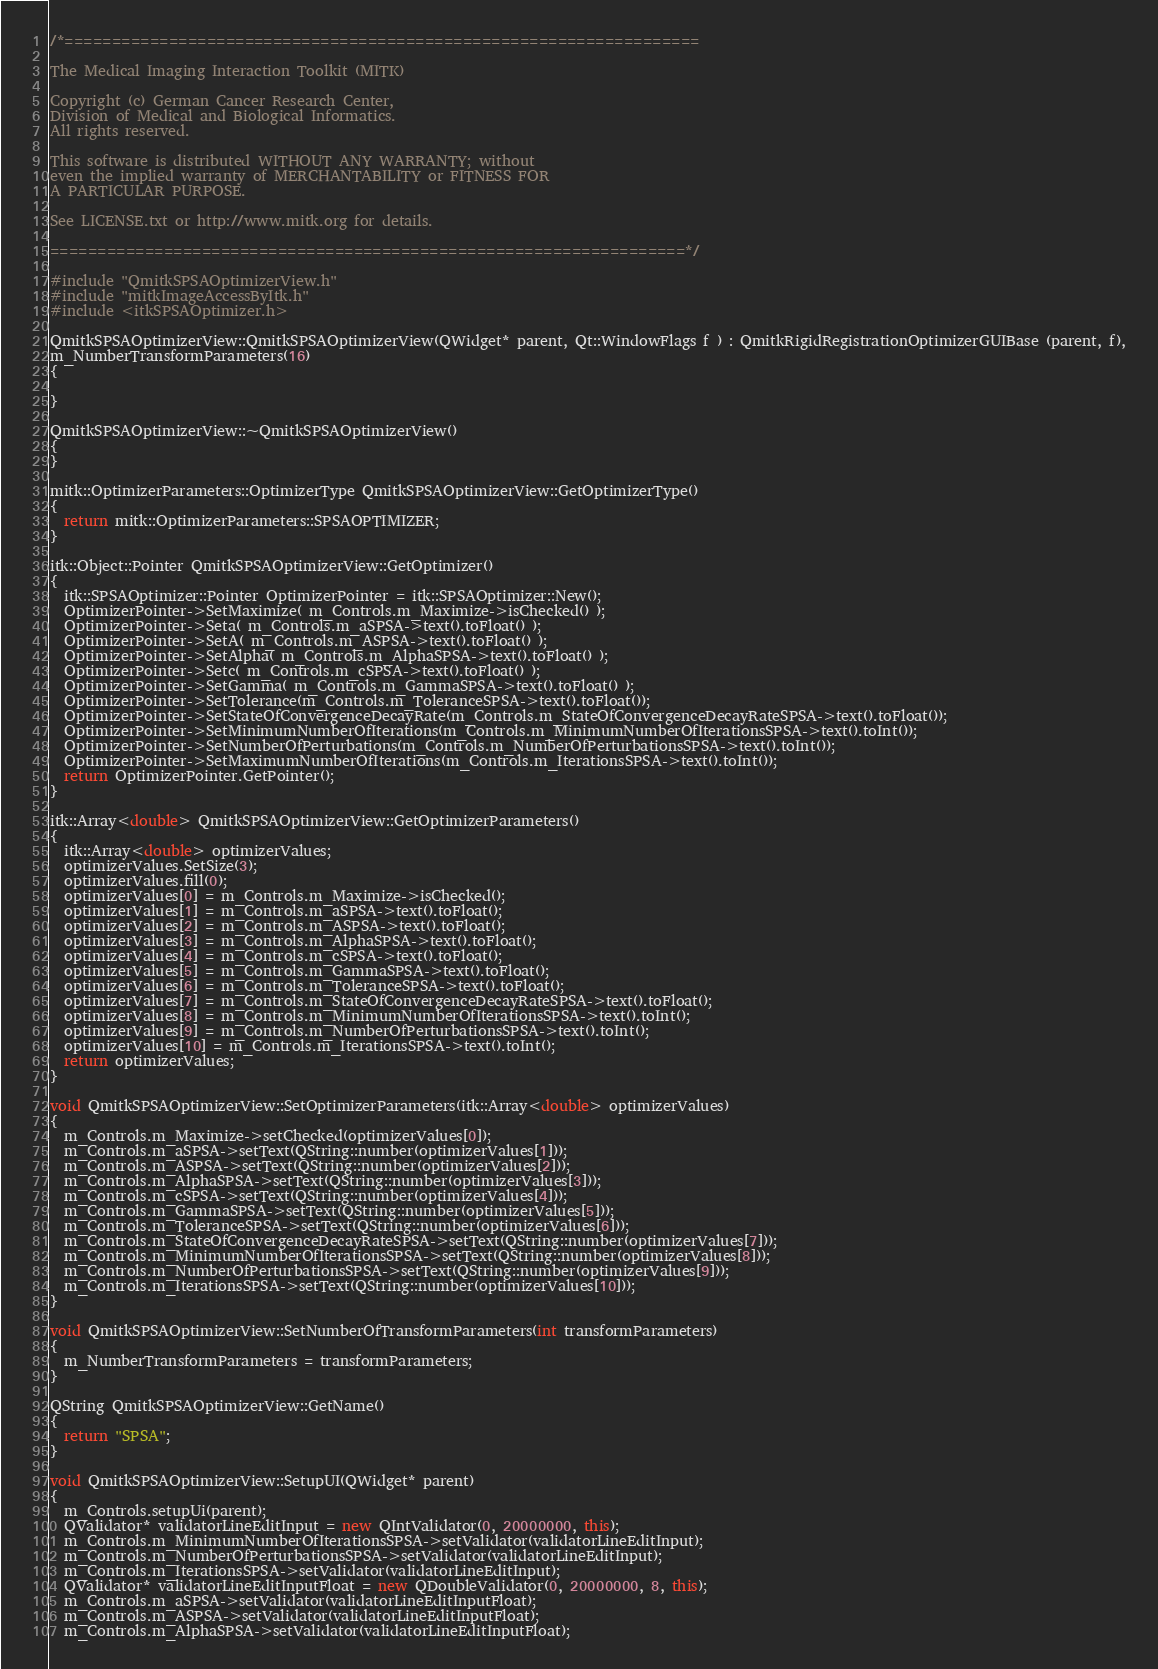Convert code to text. <code><loc_0><loc_0><loc_500><loc_500><_C++_>/*===================================================================

The Medical Imaging Interaction Toolkit (MITK)

Copyright (c) German Cancer Research Center,
Division of Medical and Biological Informatics.
All rights reserved.

This software is distributed WITHOUT ANY WARRANTY; without
even the implied warranty of MERCHANTABILITY or FITNESS FOR
A PARTICULAR PURPOSE.

See LICENSE.txt or http://www.mitk.org for details.

===================================================================*/

#include "QmitkSPSAOptimizerView.h"
#include "mitkImageAccessByItk.h"
#include <itkSPSAOptimizer.h>

QmitkSPSAOptimizerView::QmitkSPSAOptimizerView(QWidget* parent, Qt::WindowFlags f ) : QmitkRigidRegistrationOptimizerGUIBase (parent, f),
m_NumberTransformParameters(16)
{

}

QmitkSPSAOptimizerView::~QmitkSPSAOptimizerView()
{
}

mitk::OptimizerParameters::OptimizerType QmitkSPSAOptimizerView::GetOptimizerType()
{
  return mitk::OptimizerParameters::SPSAOPTIMIZER;
}

itk::Object::Pointer QmitkSPSAOptimizerView::GetOptimizer()
{
  itk::SPSAOptimizer::Pointer OptimizerPointer = itk::SPSAOptimizer::New();
  OptimizerPointer->SetMaximize( m_Controls.m_Maximize->isChecked() );
  OptimizerPointer->Seta( m_Controls.m_aSPSA->text().toFloat() );
  OptimizerPointer->SetA( m_Controls.m_ASPSA->text().toFloat() );
  OptimizerPointer->SetAlpha( m_Controls.m_AlphaSPSA->text().toFloat() );
  OptimizerPointer->Setc( m_Controls.m_cSPSA->text().toFloat() );
  OptimizerPointer->SetGamma( m_Controls.m_GammaSPSA->text().toFloat() );
  OptimizerPointer->SetTolerance(m_Controls.m_ToleranceSPSA->text().toFloat());
  OptimizerPointer->SetStateOfConvergenceDecayRate(m_Controls.m_StateOfConvergenceDecayRateSPSA->text().toFloat());
  OptimizerPointer->SetMinimumNumberOfIterations(m_Controls.m_MinimumNumberOfIterationsSPSA->text().toInt());
  OptimizerPointer->SetNumberOfPerturbations(m_Controls.m_NumberOfPerturbationsSPSA->text().toInt());
  OptimizerPointer->SetMaximumNumberOfIterations(m_Controls.m_IterationsSPSA->text().toInt());
  return OptimizerPointer.GetPointer();
}

itk::Array<double> QmitkSPSAOptimizerView::GetOptimizerParameters()
{
  itk::Array<double> optimizerValues;
  optimizerValues.SetSize(3);
  optimizerValues.fill(0);
  optimizerValues[0] = m_Controls.m_Maximize->isChecked();
  optimizerValues[1] = m_Controls.m_aSPSA->text().toFloat();
  optimizerValues[2] = m_Controls.m_ASPSA->text().toFloat();
  optimizerValues[3] = m_Controls.m_AlphaSPSA->text().toFloat();
  optimizerValues[4] = m_Controls.m_cSPSA->text().toFloat();
  optimizerValues[5] = m_Controls.m_GammaSPSA->text().toFloat();
  optimizerValues[6] = m_Controls.m_ToleranceSPSA->text().toFloat();
  optimizerValues[7] = m_Controls.m_StateOfConvergenceDecayRateSPSA->text().toFloat();
  optimizerValues[8] = m_Controls.m_MinimumNumberOfIterationsSPSA->text().toInt();
  optimizerValues[9] = m_Controls.m_NumberOfPerturbationsSPSA->text().toInt();
  optimizerValues[10] = m_Controls.m_IterationsSPSA->text().toInt();
  return optimizerValues;
}

void QmitkSPSAOptimizerView::SetOptimizerParameters(itk::Array<double> optimizerValues)
{
  m_Controls.m_Maximize->setChecked(optimizerValues[0]);
  m_Controls.m_aSPSA->setText(QString::number(optimizerValues[1]));
  m_Controls.m_ASPSA->setText(QString::number(optimizerValues[2]));
  m_Controls.m_AlphaSPSA->setText(QString::number(optimizerValues[3]));
  m_Controls.m_cSPSA->setText(QString::number(optimizerValues[4]));
  m_Controls.m_GammaSPSA->setText(QString::number(optimizerValues[5]));
  m_Controls.m_ToleranceSPSA->setText(QString::number(optimizerValues[6]));
  m_Controls.m_StateOfConvergenceDecayRateSPSA->setText(QString::number(optimizerValues[7]));
  m_Controls.m_MinimumNumberOfIterationsSPSA->setText(QString::number(optimizerValues[8]));
  m_Controls.m_NumberOfPerturbationsSPSA->setText(QString::number(optimizerValues[9]));
  m_Controls.m_IterationsSPSA->setText(QString::number(optimizerValues[10]));
}

void QmitkSPSAOptimizerView::SetNumberOfTransformParameters(int transformParameters)
{
  m_NumberTransformParameters = transformParameters;
}

QString QmitkSPSAOptimizerView::GetName()
{
  return "SPSA";
}

void QmitkSPSAOptimizerView::SetupUI(QWidget* parent)
{
  m_Controls.setupUi(parent);
  QValidator* validatorLineEditInput = new QIntValidator(0, 20000000, this);
  m_Controls.m_MinimumNumberOfIterationsSPSA->setValidator(validatorLineEditInput);
  m_Controls.m_NumberOfPerturbationsSPSA->setValidator(validatorLineEditInput);
  m_Controls.m_IterationsSPSA->setValidator(validatorLineEditInput);
  QValidator* validatorLineEditInputFloat = new QDoubleValidator(0, 20000000, 8, this);
  m_Controls.m_aSPSA->setValidator(validatorLineEditInputFloat);
  m_Controls.m_ASPSA->setValidator(validatorLineEditInputFloat);
  m_Controls.m_AlphaSPSA->setValidator(validatorLineEditInputFloat);</code> 